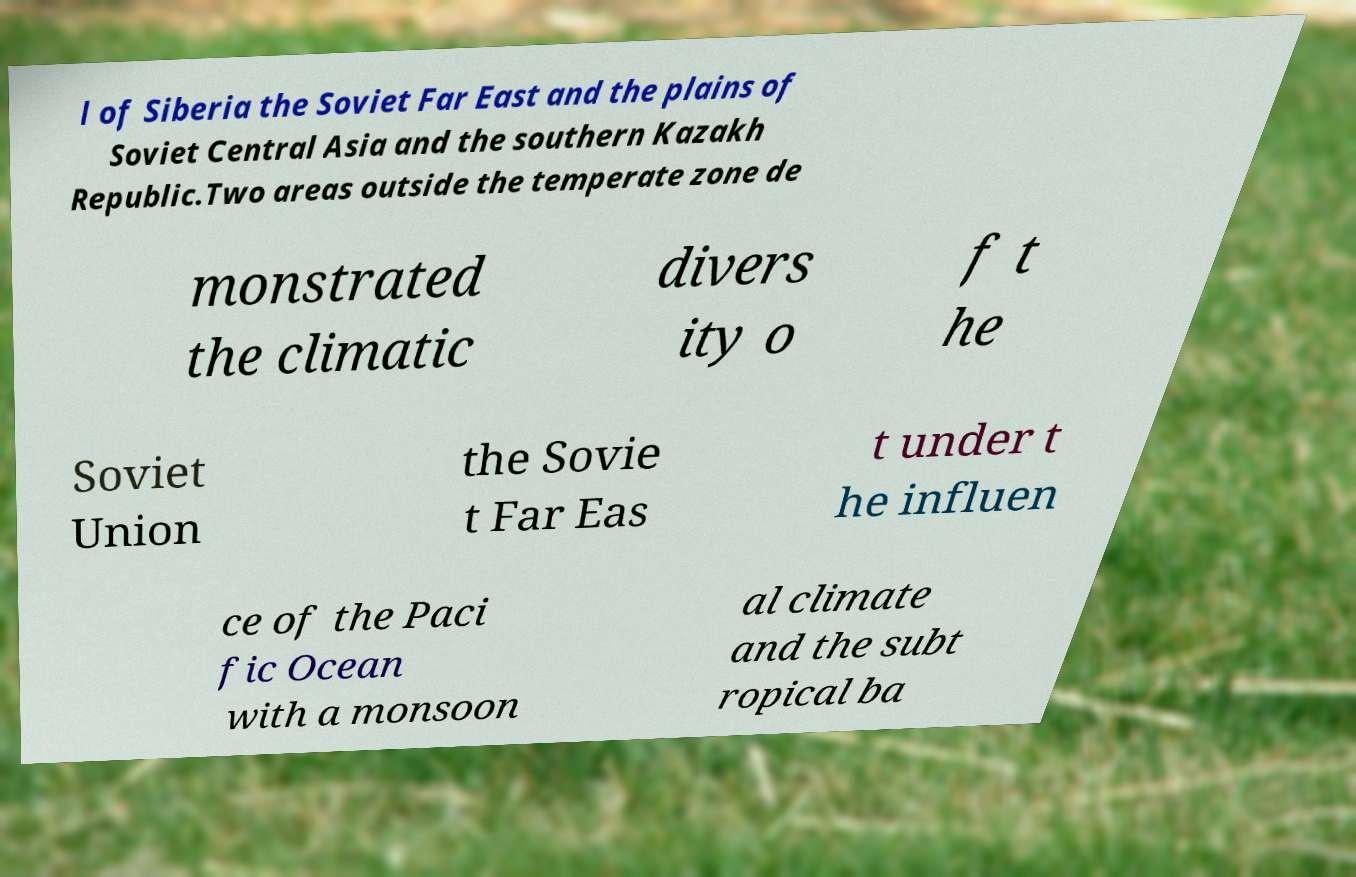Can you accurately transcribe the text from the provided image for me? l of Siberia the Soviet Far East and the plains of Soviet Central Asia and the southern Kazakh Republic.Two areas outside the temperate zone de monstrated the climatic divers ity o f t he Soviet Union the Sovie t Far Eas t under t he influen ce of the Paci fic Ocean with a monsoon al climate and the subt ropical ba 